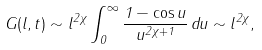Convert formula to latex. <formula><loc_0><loc_0><loc_500><loc_500>G ( l , t ) \sim l ^ { 2 \chi } \int _ { 0 } ^ { \infty } \frac { 1 - \cos u } { u ^ { 2 \chi + 1 } } \, d u \sim l ^ { 2 \chi } ,</formula> 